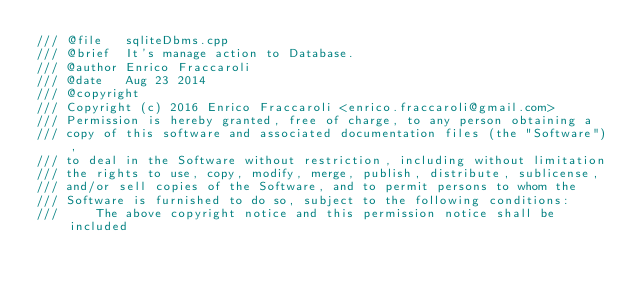Convert code to text. <code><loc_0><loc_0><loc_500><loc_500><_C++_>/// @file   sqliteDbms.cpp
/// @brief  It's manage action to Database.
/// @author Enrico Fraccaroli
/// @date   Aug 23 2014
/// @copyright
/// Copyright (c) 2016 Enrico Fraccaroli <enrico.fraccaroli@gmail.com>
/// Permission is hereby granted, free of charge, to any person obtaining a
/// copy of this software and associated documentation files (the "Software"),
/// to deal in the Software without restriction, including without limitation
/// the rights to use, copy, modify, merge, publish, distribute, sublicense,
/// and/or sell copies of the Software, and to permit persons to whom the
/// Software is furnished to do so, subject to the following conditions:
///     The above copyright notice and this permission notice shall be included</code> 